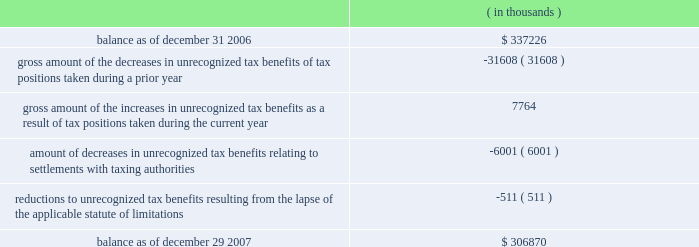The changes in the gross amount of unrecognized tax benefits for the year ended december 29 , 2007 are as follows: .
As of december 29 , 2007 , $ 228.4 million of unrecognized tax benefits would , if recognized , reduce the effective tax rate , as compared to $ 232.1 million as of december 31 , 2006 , the first day of cadence 2019s fiscal year .
The total amounts of interest and penalties recognized in the consolidated income statement for the year ended december 29 , 2007 resulted in net tax benefits of $ 11.1 million and $ 0.4 million , respectively , primarily due to the effective settlement of tax audits during the year .
The total amounts of gross accrued interest and penalties recognized in the consolidated balance sheets as of december 29 , 2007 , were $ 47.9 million and $ 9.7 million , respectively as compared to $ 65.8 million and $ 10.1 million , respectively as of december 31 , 2006 .
Note 9 .
Acquisitions for each of the acquisitions described below , the results of operations and the estimated fair value of the assets acquired and liabilities assumed have been included in cadence 2019s consolidated financial statements from the date of the acquisition .
Comparative pro forma financial information for all 2007 , 2006 and 2005 acquisitions have not been presented because the results of operations were not material to cadence 2019s consolidated financial statements .
2007 acquisitions during 2007 , cadence acquired invarium , inc. , a san jose-based developer of advanced lithography-modeling and pattern-synthesis technology , and clear shape technologies , inc. , a san jose-based design for manufacturing technology company specializing in design-side solutions to minimize yield loss for advanced semiconductor integrated circuits .
Cadence acquired these two companies for an aggregate purchase price of $ 75.5 million , which included the payment of cash , the fair value of assumed options and acquisition costs .
The $ 45.7 million of goodwill recorded in connection with these acquisitions is not expected to be deductible for income tax purposes .
Prior to acquiring clear shape technologies , inc. , cadence had an investment of $ 2.0 million in the company , representing a 12% ( 12 % ) ownership interest , which had been accounted for under the cost method of accounting .
In accordance with sfas no .
141 , 201cbusiness combinations , 201d cadence accounted for this acquisition as a step acquisition .
Subsequent adjustments to the purchase price of these acquired companies are included in the 201cother 201d line of the changes of goodwill table in note 10 below .
2006 acquisition in march 2006 , cadence acquired a company for an aggregate initial purchase price of $ 25.8 million , which included the payment of cash , the fair value of assumed options and acquisition costs .
The preliminary allocation of the purchase price was recorded as $ 17.4 million of goodwill , $ 9.4 million of identifiable intangible assets and $ ( 1.0 ) million of net liabilities .
The $ 17.4 million of goodwill recorded in connection with this acquisition is not expected to be deductible for income tax purposes .
Subsequent adjustments to the purchase price of this acquired company are included in the 201cother 201d line of the changes of goodwill table in note 10 below. .
What is the percentage change in the gross amount of unrecognized tax benefit during 2007? 
Computations: ((306870 - 337226) / 337226)
Answer: -0.09002. 